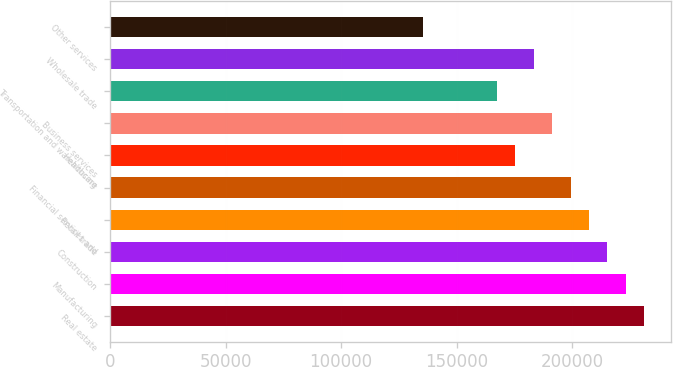<chart> <loc_0><loc_0><loc_500><loc_500><bar_chart><fcel>Real estate<fcel>Manufacturing<fcel>Construction<fcel>Retail trade<fcel>Financial services and<fcel>Healthcare<fcel>Business services<fcel>Transportation and warehousing<fcel>Wholesale trade<fcel>Other services<nl><fcel>231362<fcel>223384<fcel>215406<fcel>207428<fcel>199450<fcel>175517<fcel>191473<fcel>167539<fcel>183495<fcel>135627<nl></chart> 